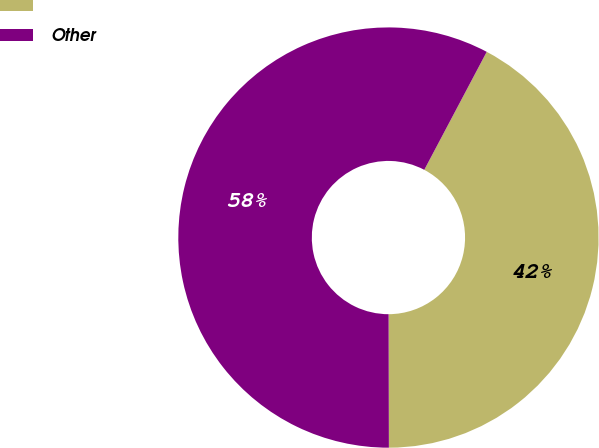Convert chart. <chart><loc_0><loc_0><loc_500><loc_500><pie_chart><ecel><fcel>Other<nl><fcel>42.22%<fcel>57.78%<nl></chart> 